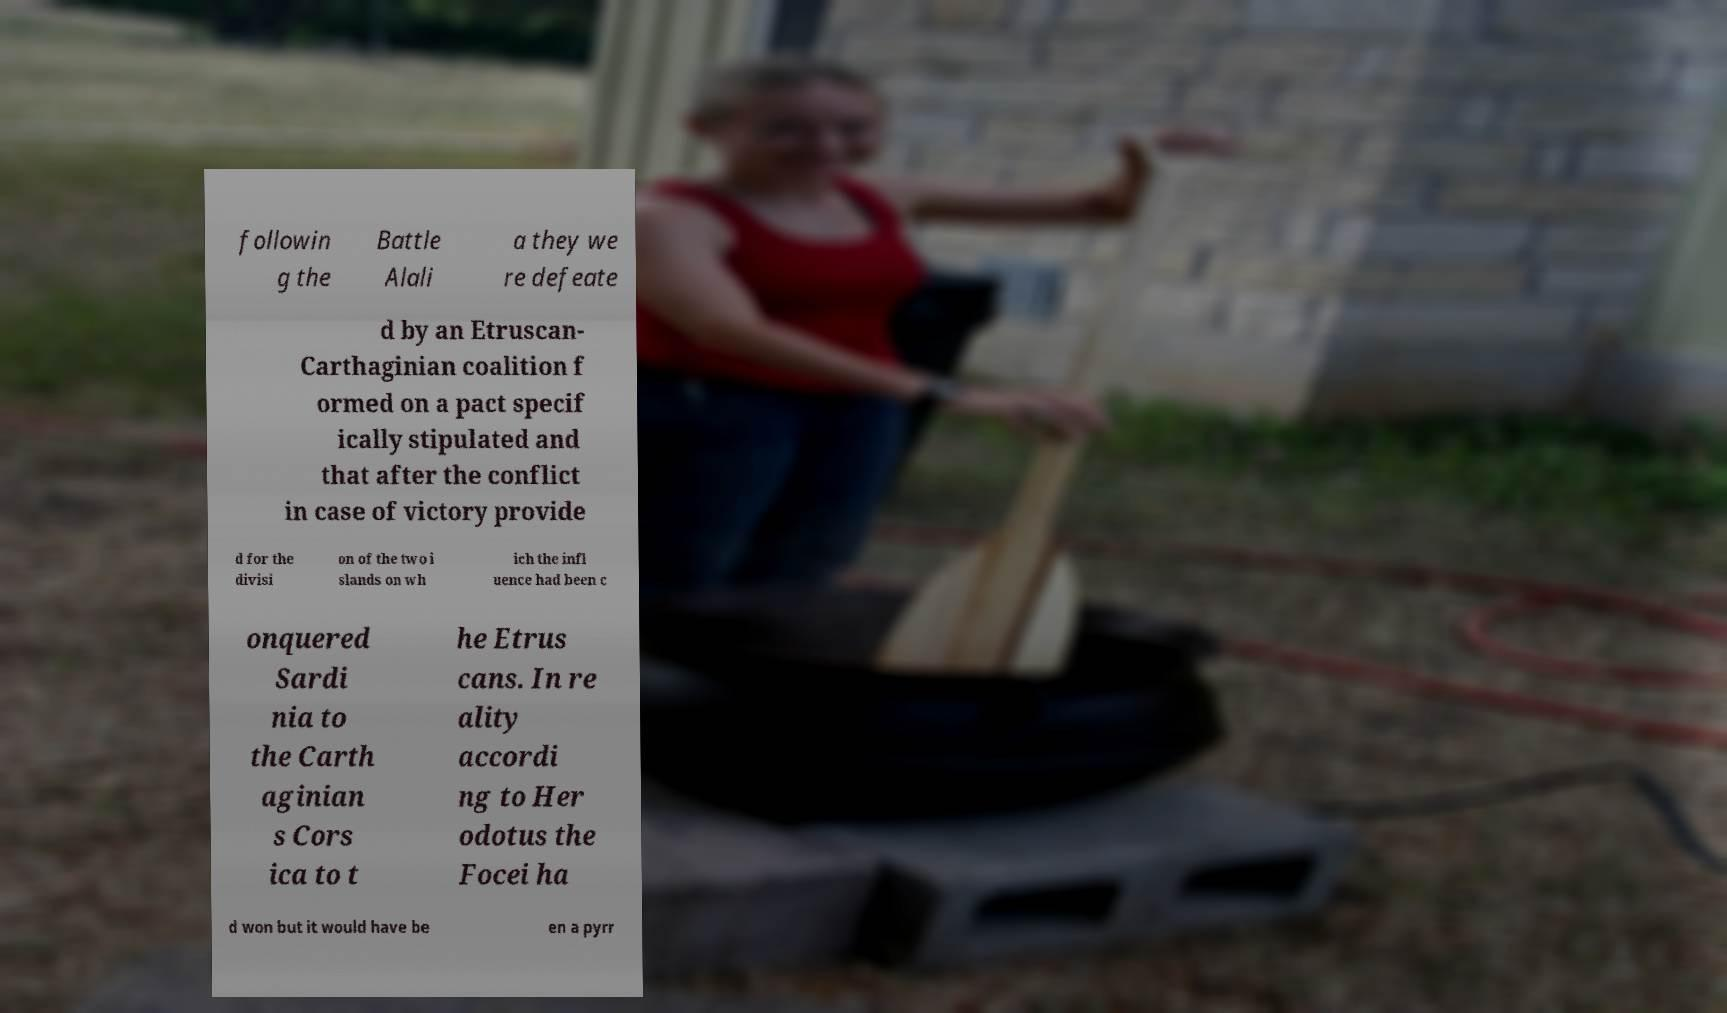Could you extract and type out the text from this image? followin g the Battle Alali a they we re defeate d by an Etruscan- Carthaginian coalition f ormed on a pact specif ically stipulated and that after the conflict in case of victory provide d for the divisi on of the two i slands on wh ich the infl uence had been c onquered Sardi nia to the Carth aginian s Cors ica to t he Etrus cans. In re ality accordi ng to Her odotus the Focei ha d won but it would have be en a pyrr 